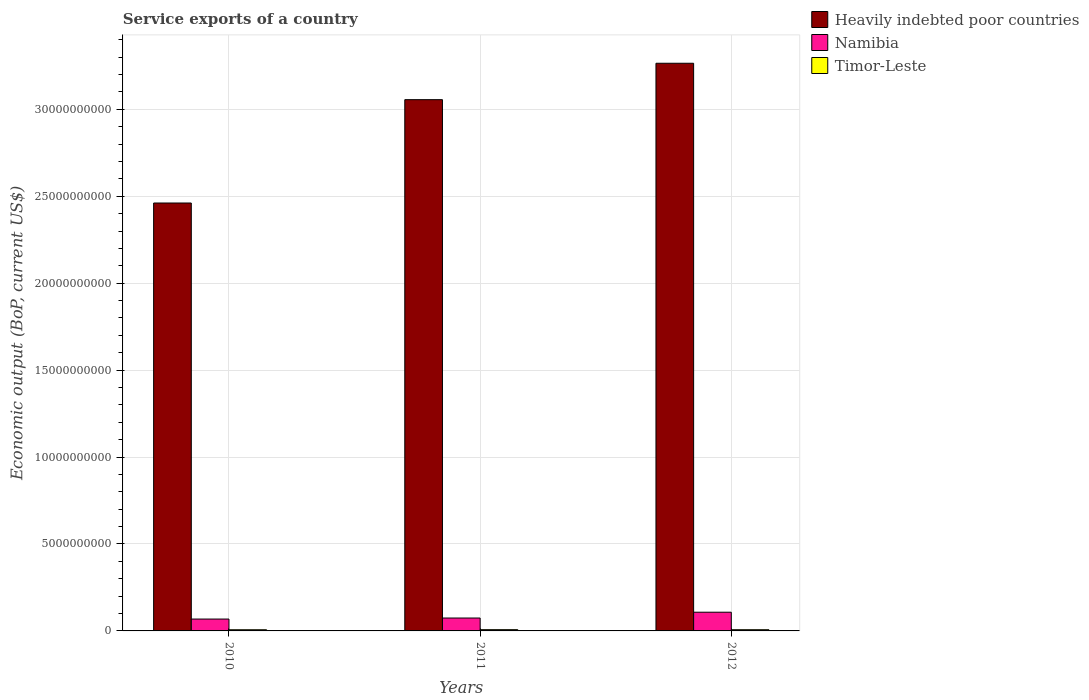How many groups of bars are there?
Your answer should be compact. 3. Are the number of bars per tick equal to the number of legend labels?
Your answer should be very brief. Yes. How many bars are there on the 1st tick from the left?
Offer a terse response. 3. How many bars are there on the 2nd tick from the right?
Offer a terse response. 3. What is the service exports in Timor-Leste in 2012?
Make the answer very short. 6.94e+07. Across all years, what is the maximum service exports in Heavily indebted poor countries?
Your answer should be compact. 3.27e+1. Across all years, what is the minimum service exports in Namibia?
Ensure brevity in your answer.  6.83e+08. What is the total service exports in Heavily indebted poor countries in the graph?
Your answer should be very brief. 8.78e+1. What is the difference between the service exports in Namibia in 2010 and that in 2012?
Provide a succinct answer. -3.93e+08. What is the difference between the service exports in Timor-Leste in 2010 and the service exports in Namibia in 2012?
Offer a very short reply. -1.01e+09. What is the average service exports in Heavily indebted poor countries per year?
Ensure brevity in your answer.  2.93e+1. In the year 2010, what is the difference between the service exports in Namibia and service exports in Timor-Leste?
Your response must be concise. 6.15e+08. What is the ratio of the service exports in Namibia in 2011 to that in 2012?
Your answer should be very brief. 0.69. Is the service exports in Namibia in 2010 less than that in 2012?
Offer a very short reply. Yes. What is the difference between the highest and the second highest service exports in Heavily indebted poor countries?
Ensure brevity in your answer.  2.09e+09. What is the difference between the highest and the lowest service exports in Timor-Leste?
Provide a succinct answer. 4.77e+06. Is the sum of the service exports in Timor-Leste in 2011 and 2012 greater than the maximum service exports in Namibia across all years?
Provide a short and direct response. No. What does the 1st bar from the left in 2010 represents?
Your answer should be very brief. Heavily indebted poor countries. What does the 1st bar from the right in 2010 represents?
Provide a succinct answer. Timor-Leste. How many bars are there?
Make the answer very short. 9. How many years are there in the graph?
Offer a terse response. 3. Are the values on the major ticks of Y-axis written in scientific E-notation?
Your answer should be very brief. No. Does the graph contain any zero values?
Ensure brevity in your answer.  No. Where does the legend appear in the graph?
Provide a short and direct response. Top right. How are the legend labels stacked?
Your response must be concise. Vertical. What is the title of the graph?
Your answer should be compact. Service exports of a country. Does "East Asia (developing only)" appear as one of the legend labels in the graph?
Ensure brevity in your answer.  No. What is the label or title of the X-axis?
Your answer should be very brief. Years. What is the label or title of the Y-axis?
Your answer should be very brief. Economic output (BoP, current US$). What is the Economic output (BoP, current US$) of Heavily indebted poor countries in 2010?
Make the answer very short. 2.46e+1. What is the Economic output (BoP, current US$) of Namibia in 2010?
Provide a succinct answer. 6.83e+08. What is the Economic output (BoP, current US$) of Timor-Leste in 2010?
Make the answer very short. 6.78e+07. What is the Economic output (BoP, current US$) in Heavily indebted poor countries in 2011?
Keep it short and to the point. 3.06e+1. What is the Economic output (BoP, current US$) in Namibia in 2011?
Offer a terse response. 7.42e+08. What is the Economic output (BoP, current US$) in Timor-Leste in 2011?
Give a very brief answer. 7.26e+07. What is the Economic output (BoP, current US$) in Heavily indebted poor countries in 2012?
Give a very brief answer. 3.27e+1. What is the Economic output (BoP, current US$) of Namibia in 2012?
Provide a short and direct response. 1.08e+09. What is the Economic output (BoP, current US$) in Timor-Leste in 2012?
Give a very brief answer. 6.94e+07. Across all years, what is the maximum Economic output (BoP, current US$) in Heavily indebted poor countries?
Your answer should be compact. 3.27e+1. Across all years, what is the maximum Economic output (BoP, current US$) in Namibia?
Give a very brief answer. 1.08e+09. Across all years, what is the maximum Economic output (BoP, current US$) in Timor-Leste?
Give a very brief answer. 7.26e+07. Across all years, what is the minimum Economic output (BoP, current US$) in Heavily indebted poor countries?
Provide a succinct answer. 2.46e+1. Across all years, what is the minimum Economic output (BoP, current US$) of Namibia?
Ensure brevity in your answer.  6.83e+08. Across all years, what is the minimum Economic output (BoP, current US$) in Timor-Leste?
Offer a terse response. 6.78e+07. What is the total Economic output (BoP, current US$) of Heavily indebted poor countries in the graph?
Your answer should be very brief. 8.78e+1. What is the total Economic output (BoP, current US$) in Namibia in the graph?
Make the answer very short. 2.50e+09. What is the total Economic output (BoP, current US$) of Timor-Leste in the graph?
Provide a short and direct response. 2.10e+08. What is the difference between the Economic output (BoP, current US$) in Heavily indebted poor countries in 2010 and that in 2011?
Give a very brief answer. -5.94e+09. What is the difference between the Economic output (BoP, current US$) of Namibia in 2010 and that in 2011?
Ensure brevity in your answer.  -5.92e+07. What is the difference between the Economic output (BoP, current US$) in Timor-Leste in 2010 and that in 2011?
Keep it short and to the point. -4.77e+06. What is the difference between the Economic output (BoP, current US$) in Heavily indebted poor countries in 2010 and that in 2012?
Your response must be concise. -8.04e+09. What is the difference between the Economic output (BoP, current US$) in Namibia in 2010 and that in 2012?
Provide a succinct answer. -3.93e+08. What is the difference between the Economic output (BoP, current US$) of Timor-Leste in 2010 and that in 2012?
Keep it short and to the point. -1.61e+06. What is the difference between the Economic output (BoP, current US$) in Heavily indebted poor countries in 2011 and that in 2012?
Ensure brevity in your answer.  -2.09e+09. What is the difference between the Economic output (BoP, current US$) of Namibia in 2011 and that in 2012?
Your response must be concise. -3.34e+08. What is the difference between the Economic output (BoP, current US$) in Timor-Leste in 2011 and that in 2012?
Offer a terse response. 3.16e+06. What is the difference between the Economic output (BoP, current US$) in Heavily indebted poor countries in 2010 and the Economic output (BoP, current US$) in Namibia in 2011?
Your answer should be very brief. 2.39e+1. What is the difference between the Economic output (BoP, current US$) in Heavily indebted poor countries in 2010 and the Economic output (BoP, current US$) in Timor-Leste in 2011?
Offer a terse response. 2.45e+1. What is the difference between the Economic output (BoP, current US$) of Namibia in 2010 and the Economic output (BoP, current US$) of Timor-Leste in 2011?
Give a very brief answer. 6.10e+08. What is the difference between the Economic output (BoP, current US$) of Heavily indebted poor countries in 2010 and the Economic output (BoP, current US$) of Namibia in 2012?
Give a very brief answer. 2.35e+1. What is the difference between the Economic output (BoP, current US$) in Heavily indebted poor countries in 2010 and the Economic output (BoP, current US$) in Timor-Leste in 2012?
Your answer should be very brief. 2.45e+1. What is the difference between the Economic output (BoP, current US$) of Namibia in 2010 and the Economic output (BoP, current US$) of Timor-Leste in 2012?
Give a very brief answer. 6.13e+08. What is the difference between the Economic output (BoP, current US$) in Heavily indebted poor countries in 2011 and the Economic output (BoP, current US$) in Namibia in 2012?
Ensure brevity in your answer.  2.95e+1. What is the difference between the Economic output (BoP, current US$) of Heavily indebted poor countries in 2011 and the Economic output (BoP, current US$) of Timor-Leste in 2012?
Your response must be concise. 3.05e+1. What is the difference between the Economic output (BoP, current US$) in Namibia in 2011 and the Economic output (BoP, current US$) in Timor-Leste in 2012?
Your answer should be very brief. 6.73e+08. What is the average Economic output (BoP, current US$) of Heavily indebted poor countries per year?
Provide a succinct answer. 2.93e+1. What is the average Economic output (BoP, current US$) in Namibia per year?
Give a very brief answer. 8.34e+08. What is the average Economic output (BoP, current US$) of Timor-Leste per year?
Keep it short and to the point. 6.99e+07. In the year 2010, what is the difference between the Economic output (BoP, current US$) in Heavily indebted poor countries and Economic output (BoP, current US$) in Namibia?
Offer a terse response. 2.39e+1. In the year 2010, what is the difference between the Economic output (BoP, current US$) in Heavily indebted poor countries and Economic output (BoP, current US$) in Timor-Leste?
Your response must be concise. 2.45e+1. In the year 2010, what is the difference between the Economic output (BoP, current US$) of Namibia and Economic output (BoP, current US$) of Timor-Leste?
Provide a succinct answer. 6.15e+08. In the year 2011, what is the difference between the Economic output (BoP, current US$) of Heavily indebted poor countries and Economic output (BoP, current US$) of Namibia?
Your response must be concise. 2.98e+1. In the year 2011, what is the difference between the Economic output (BoP, current US$) in Heavily indebted poor countries and Economic output (BoP, current US$) in Timor-Leste?
Your response must be concise. 3.05e+1. In the year 2011, what is the difference between the Economic output (BoP, current US$) of Namibia and Economic output (BoP, current US$) of Timor-Leste?
Your answer should be very brief. 6.69e+08. In the year 2012, what is the difference between the Economic output (BoP, current US$) in Heavily indebted poor countries and Economic output (BoP, current US$) in Namibia?
Provide a succinct answer. 3.16e+1. In the year 2012, what is the difference between the Economic output (BoP, current US$) of Heavily indebted poor countries and Economic output (BoP, current US$) of Timor-Leste?
Provide a short and direct response. 3.26e+1. In the year 2012, what is the difference between the Economic output (BoP, current US$) in Namibia and Economic output (BoP, current US$) in Timor-Leste?
Provide a short and direct response. 1.01e+09. What is the ratio of the Economic output (BoP, current US$) in Heavily indebted poor countries in 2010 to that in 2011?
Provide a short and direct response. 0.81. What is the ratio of the Economic output (BoP, current US$) of Namibia in 2010 to that in 2011?
Offer a terse response. 0.92. What is the ratio of the Economic output (BoP, current US$) in Timor-Leste in 2010 to that in 2011?
Offer a very short reply. 0.93. What is the ratio of the Economic output (BoP, current US$) of Heavily indebted poor countries in 2010 to that in 2012?
Provide a short and direct response. 0.75. What is the ratio of the Economic output (BoP, current US$) of Namibia in 2010 to that in 2012?
Keep it short and to the point. 0.63. What is the ratio of the Economic output (BoP, current US$) of Timor-Leste in 2010 to that in 2012?
Your response must be concise. 0.98. What is the ratio of the Economic output (BoP, current US$) of Heavily indebted poor countries in 2011 to that in 2012?
Make the answer very short. 0.94. What is the ratio of the Economic output (BoP, current US$) of Namibia in 2011 to that in 2012?
Keep it short and to the point. 0.69. What is the ratio of the Economic output (BoP, current US$) of Timor-Leste in 2011 to that in 2012?
Make the answer very short. 1.05. What is the difference between the highest and the second highest Economic output (BoP, current US$) of Heavily indebted poor countries?
Make the answer very short. 2.09e+09. What is the difference between the highest and the second highest Economic output (BoP, current US$) of Namibia?
Keep it short and to the point. 3.34e+08. What is the difference between the highest and the second highest Economic output (BoP, current US$) of Timor-Leste?
Give a very brief answer. 3.16e+06. What is the difference between the highest and the lowest Economic output (BoP, current US$) of Heavily indebted poor countries?
Ensure brevity in your answer.  8.04e+09. What is the difference between the highest and the lowest Economic output (BoP, current US$) in Namibia?
Ensure brevity in your answer.  3.93e+08. What is the difference between the highest and the lowest Economic output (BoP, current US$) in Timor-Leste?
Make the answer very short. 4.77e+06. 